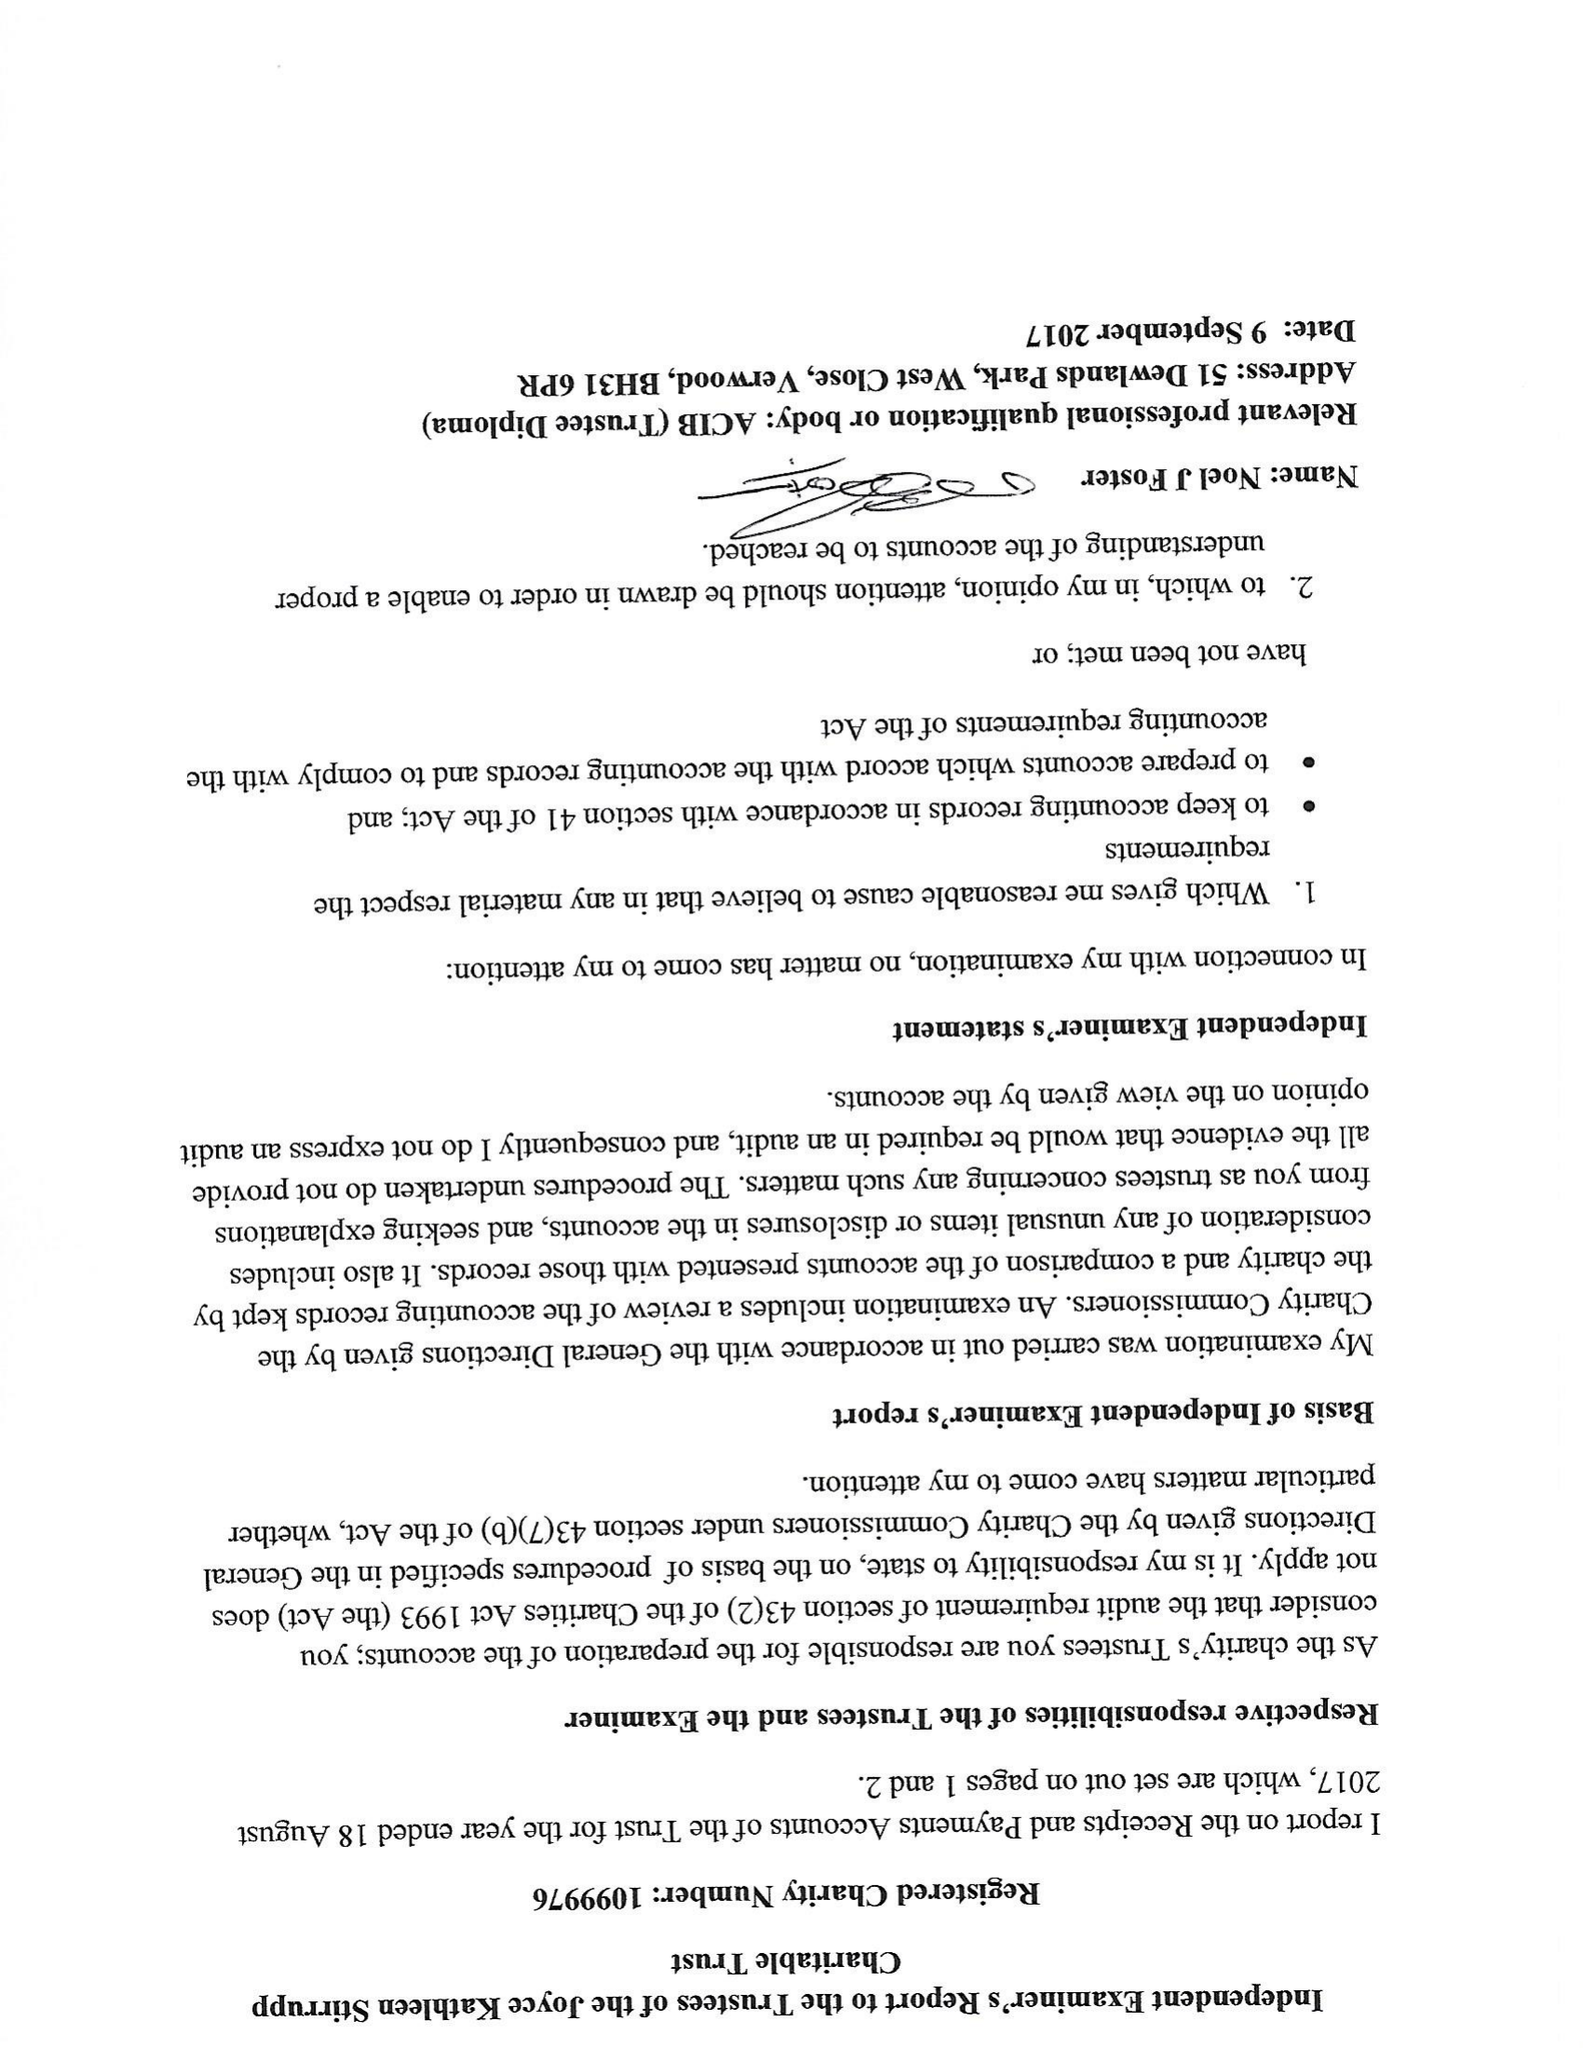What is the value for the spending_annually_in_british_pounds?
Answer the question using a single word or phrase. 140427.00 